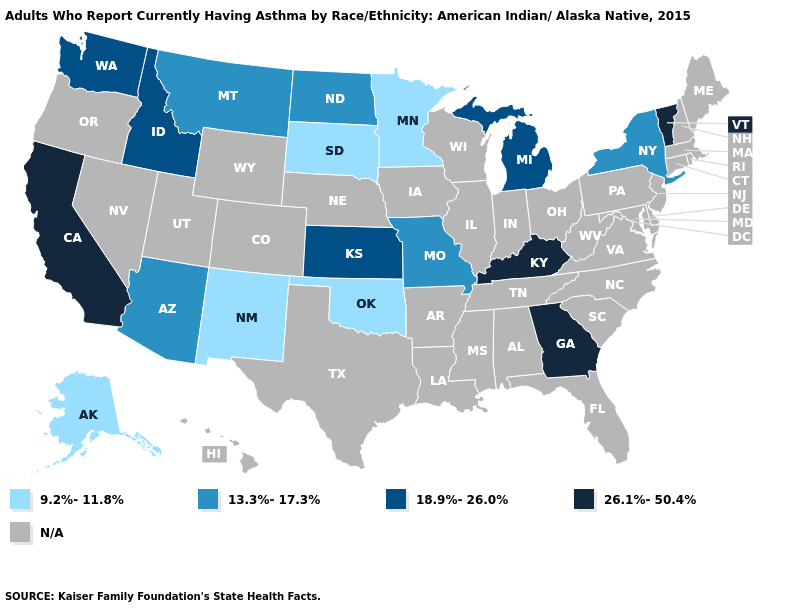What is the value of Arizona?
Keep it brief. 13.3%-17.3%. What is the value of Kentucky?
Concise answer only. 26.1%-50.4%. What is the lowest value in the MidWest?
Be succinct. 9.2%-11.8%. Does North Dakota have the lowest value in the MidWest?
Concise answer only. No. What is the value of Idaho?
Short answer required. 18.9%-26.0%. What is the value of Utah?
Keep it brief. N/A. Which states hav the highest value in the MidWest?
Short answer required. Kansas, Michigan. What is the value of Nebraska?
Keep it brief. N/A. Name the states that have a value in the range 13.3%-17.3%?
Concise answer only. Arizona, Missouri, Montana, New York, North Dakota. Name the states that have a value in the range 18.9%-26.0%?
Short answer required. Idaho, Kansas, Michigan, Washington. Which states have the lowest value in the USA?
Quick response, please. Alaska, Minnesota, New Mexico, Oklahoma, South Dakota. What is the value of Mississippi?
Write a very short answer. N/A. 